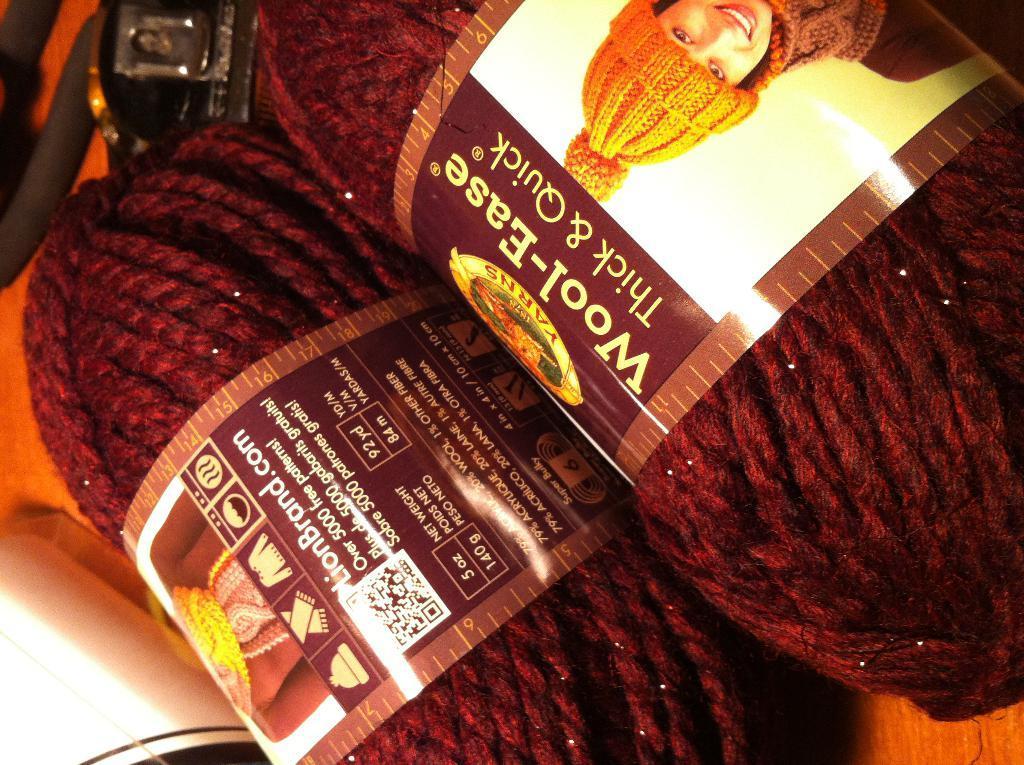Please provide a concise description of this image. These is wool, a woman is wearing cap and clothes, this is sticker. 